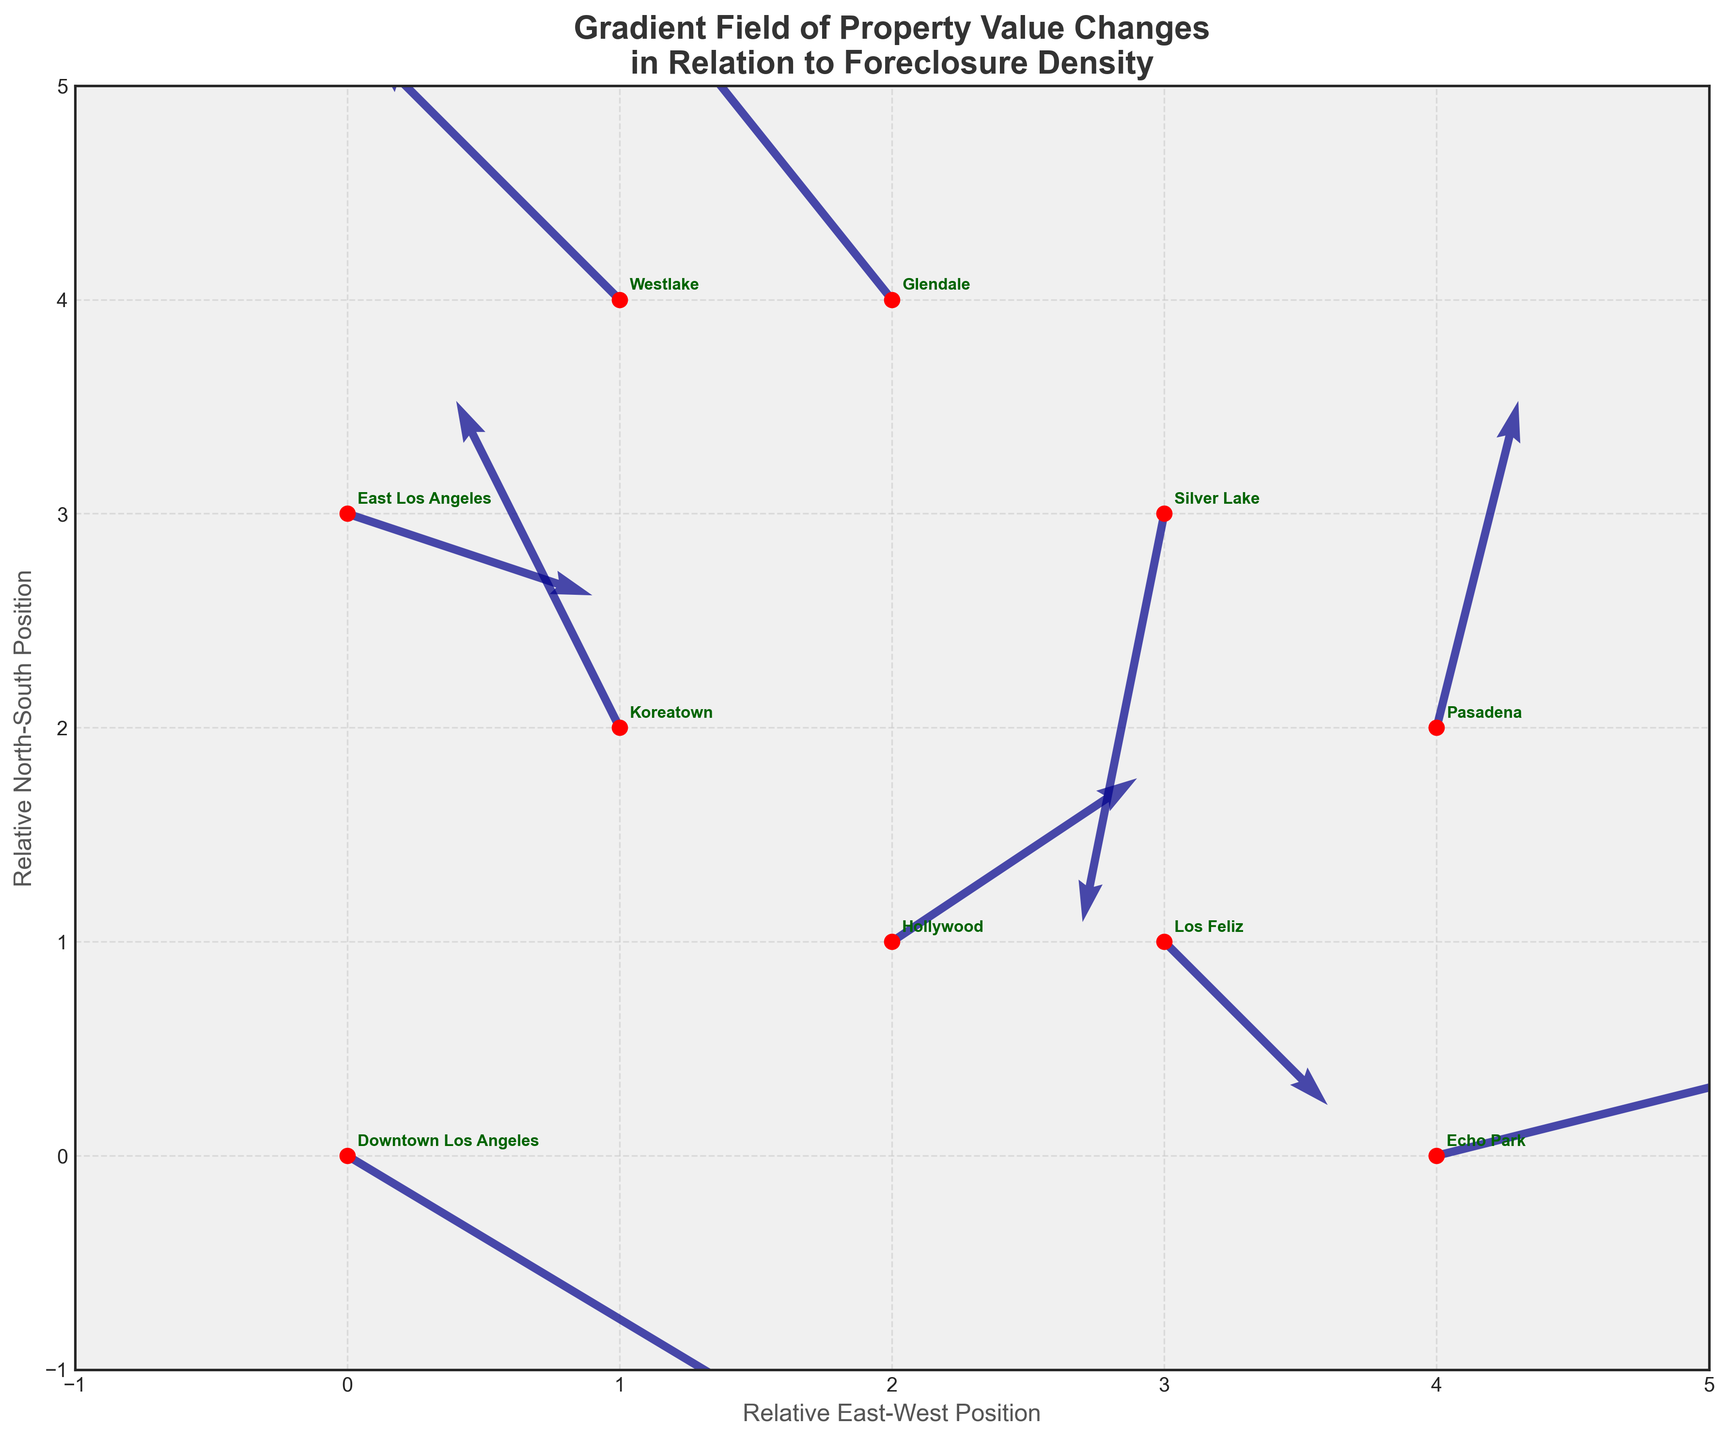Which data point has the steepest gradient vector? The steepest gradient vector is identified by the highest magnitude of (dx, dy). Calculating the magnitude for each, we find the largest at Glendale with a magnitude of sqrt((-0.4)^2 + 0.5^2) = 0.64.
Answer: Glendale What is the direction of property value change in Downtown Los Angeles? The direction of change in Downtown Los Angeles is given by the vector (0.5, -0.3), which points to the right and slightly downward.
Answer: Right and down Compare the gradients of property value in Koreatown and Silver Lake. Which one has a greater downward trend? The gradients for Koreatown and Silver Lake are (-0.2, 0.4) and (-0.1, -0.5), respectively. The more negative the y-component (dy), the greater the downward trend. Silver Lake has a greater downward trend with dy = -0.5.
Answer: Silver Lake Which location has the highest indicator of increasing property value when looking East? The highest indicator of increasing property value looking East is the one with the highest positive dx. This is Echo Park with dx = 0.4.
Answer: Echo Park How many locations show a decrease in property value (both dx and dy are negative)? We examine each vector to count locations where both dx and dy are negative: Downtown Los Angeles, Silver Lake, and Los Feliz meet this criterion.
Answer: 3 locations Is Pasadena’s property value gradient more horizontal or vertical? Pasadena's property value gradient (0.1, 0.4) has a greater dy, making it more vertical.
Answer: Vertical Which location shows the least change in property values? The least change in property values corresponds to the smallest magnitude of the gradient vector. Los Feliz, with a vector (0.2, -0.2), has the smallest magnitude of sqrt((0.2)^2 + (-0.2)^2) = 0.28.
Answer: Los Feliz What is the relative direction of property value change from Koreatown compared to Hollywood? Comparing vectors, Koreatown has a direction of (-0.2, 0.4) and Hollywood (0.3, 0.2). Koreatown generally trends west (negative x) and up (positive y), while Hollywood trends east (positive x) and up (positive y).
Answer: Koreatown: West and up vs. Hollywood: East and up 